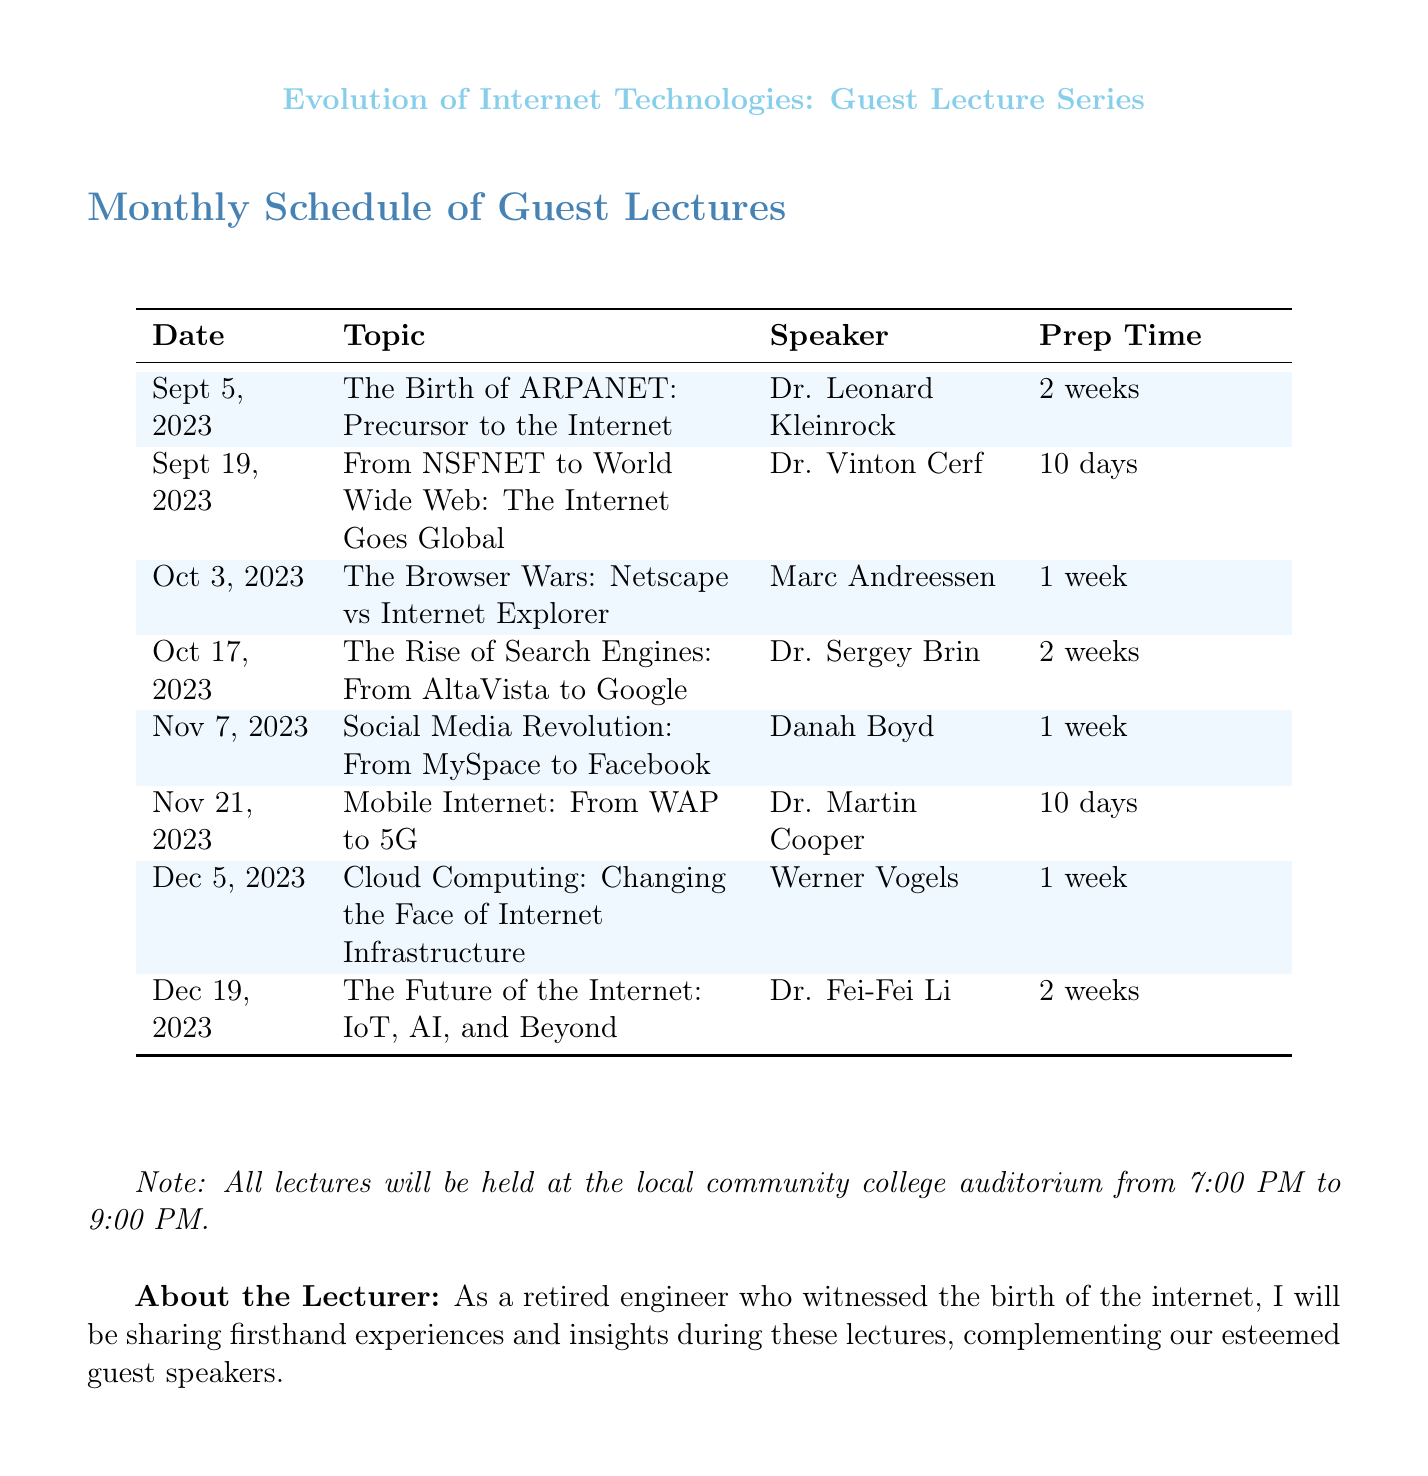What is the date of the first lecture? The first lecture is scheduled for September 5, 2023, as stated in the document.
Answer: September 5, 2023 Who is the speaker for the lecture on the Rise of Search Engines? The speaker for this topic is Dr. Sergey Brin, as indicated in the schedule.
Answer: Dr. Sergey Brin How many weeks of preparation are required for the lecture on Cloud Computing? The preparation time for the Cloud Computing lecture is stated to be 1 week in the document.
Answer: 1 week What topic will be discussed on November 21, 2023? The topic for November 21, 2023, is Mobile Internet: From WAP to 5G, as listed in the schedule.
Answer: Mobile Internet: From WAP to 5G Which speaker is associated with the lecture on the future of the Internet? The speaker for the lecture on the future of the Internet is Dr. Fei-Fei Li, according to the document.
Answer: Dr. Fei-Fei Li How long is the lecture series scheduled to last? The lecture series is scheduled from September 5, 2023, to December 19, 2023, making it span over several months.
Answer: Several months What will be the venue for the lectures? The venue for all lectures is mentioned to be the local community college auditorium.
Answer: Local community college auditorium What is the primary focus of the guest lecture series? The primary focus is on the evolution of internet technologies, as outlined in the title of the document.
Answer: Evolution of internet technologies 